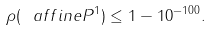<formula> <loc_0><loc_0><loc_500><loc_500>\rho ( \ a f f i n e P ^ { 1 } ) \leq 1 - 1 0 ^ { - 1 0 0 } .</formula> 